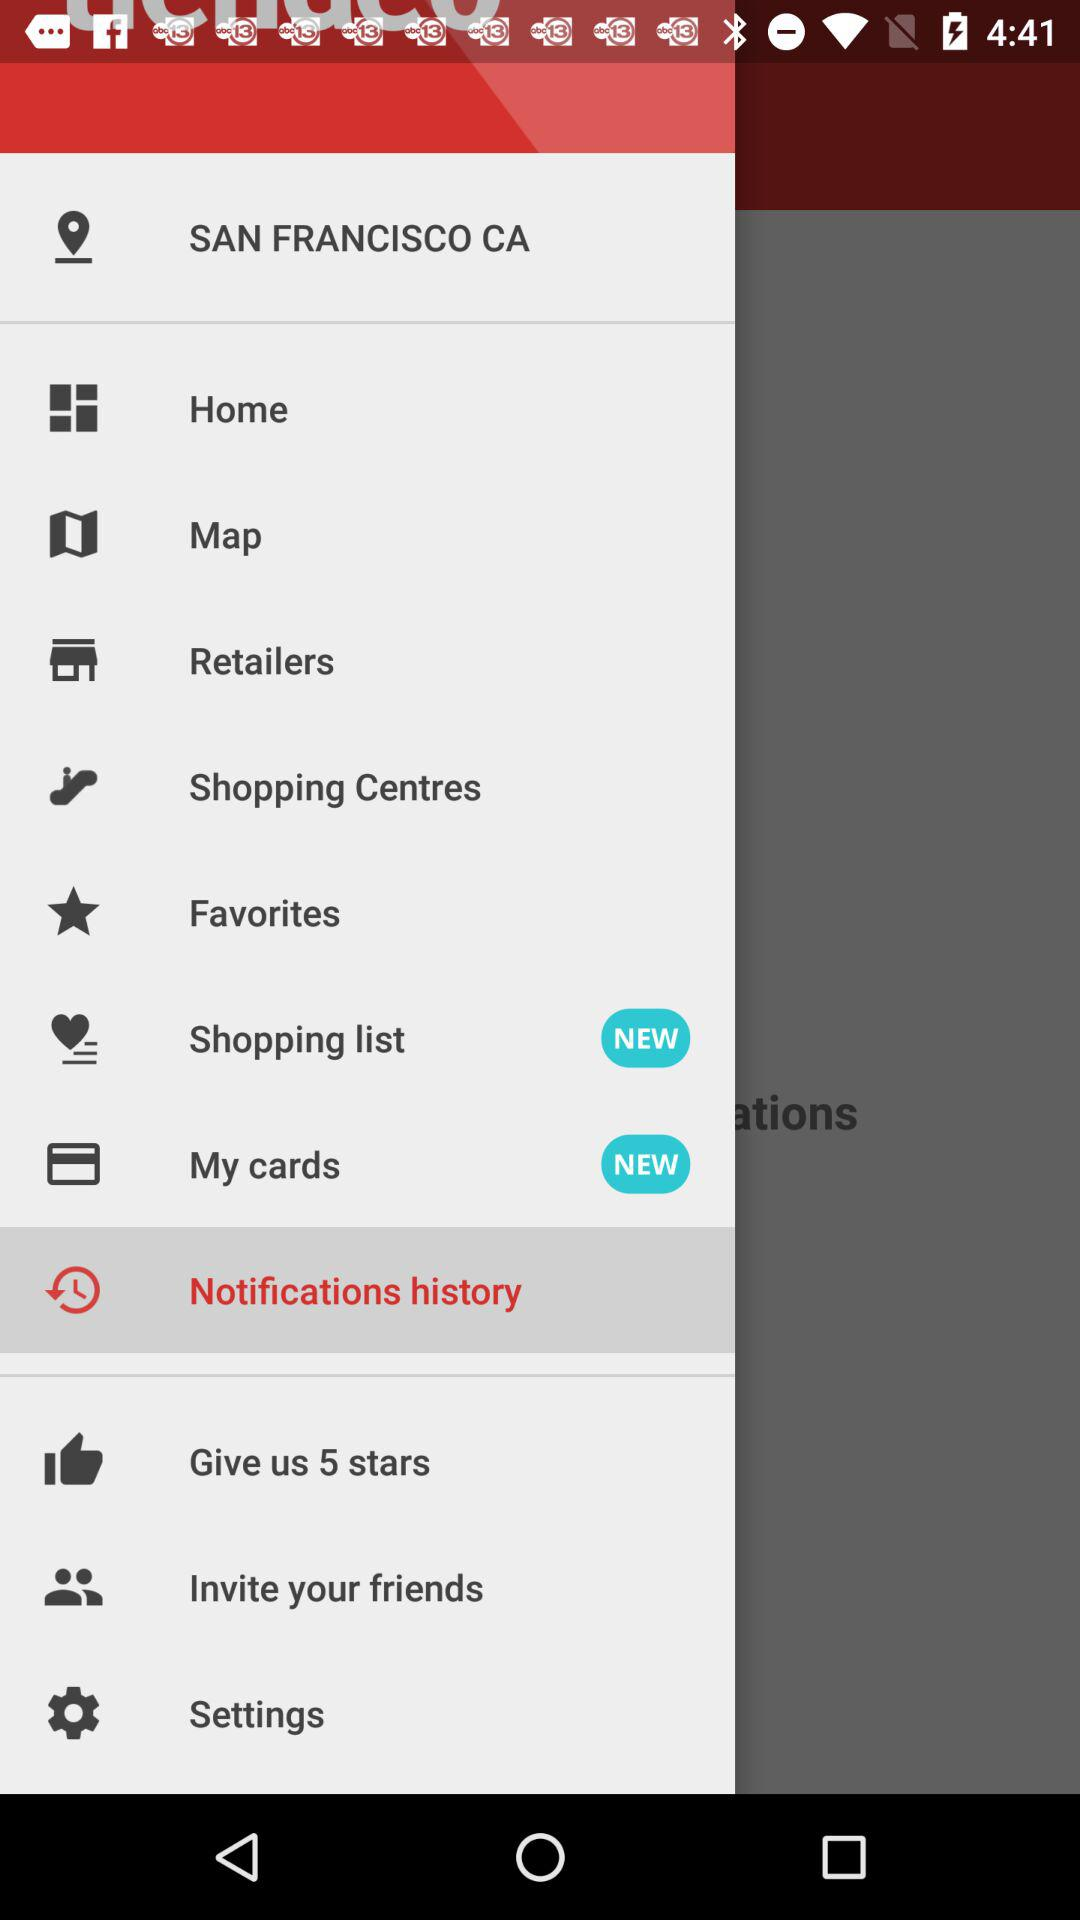Which items are available in the new additions? The items available in the new additions are "Shopping list" and "My cards". 